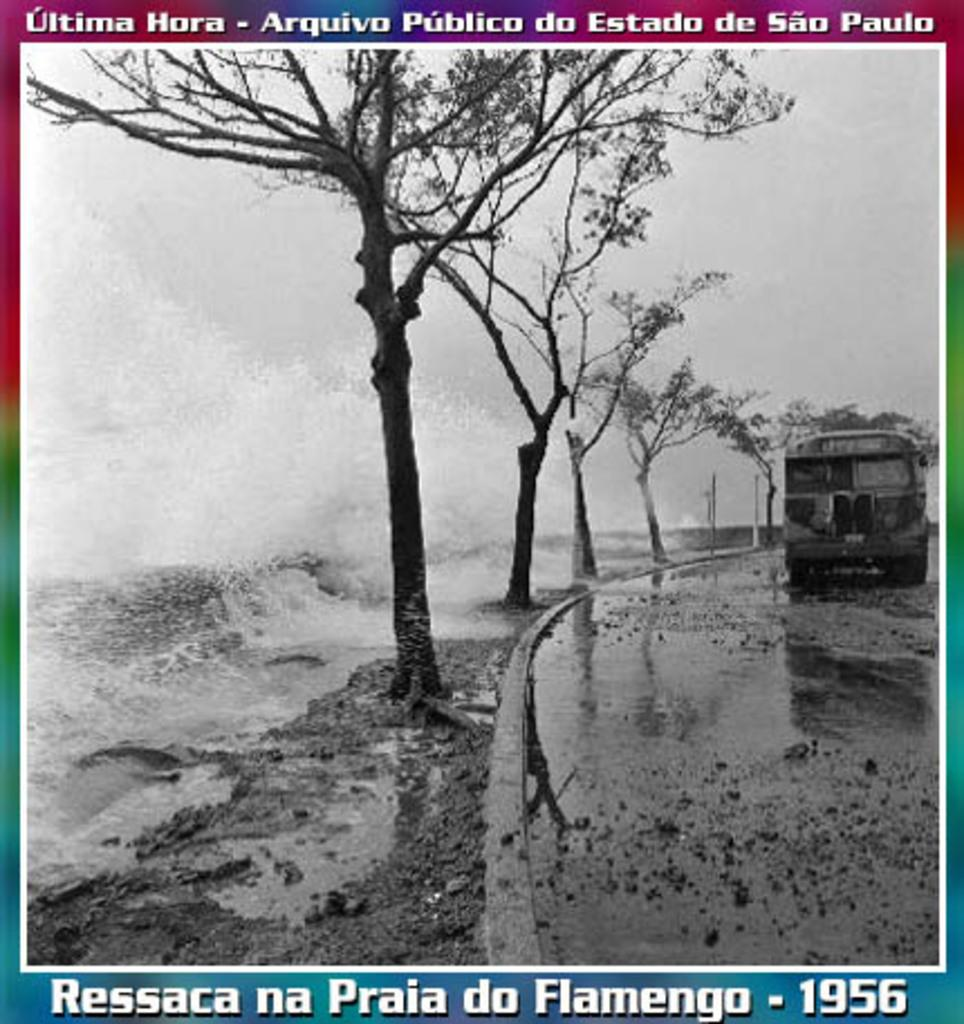<image>
Provide a brief description of the given image. An album cover from 1956 shows a wet road with a bus on it. 